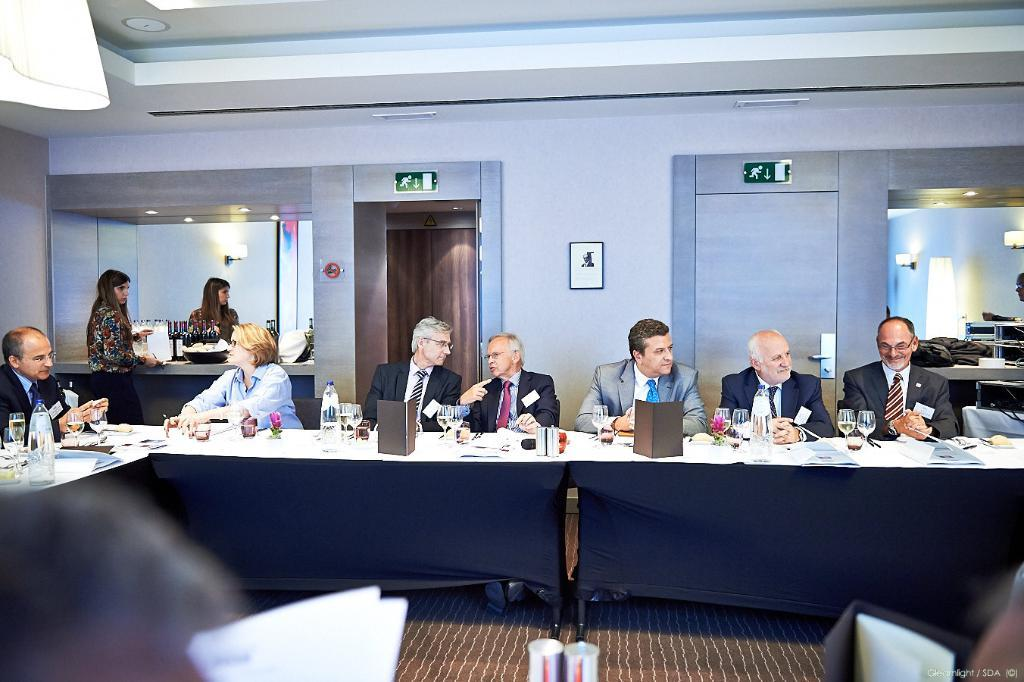What is happening in the image? There are people sitting at a table, and the setting is a party. Can you describe the people at the table? Unfortunately, the image does not provide enough detail to describe the people at the table. What is the woman doing in the image? The woman is standing behind the people at the table. What type of car is parked in front of the shop during the lumber event? There is no car, shop, or lumber event present in the image. 